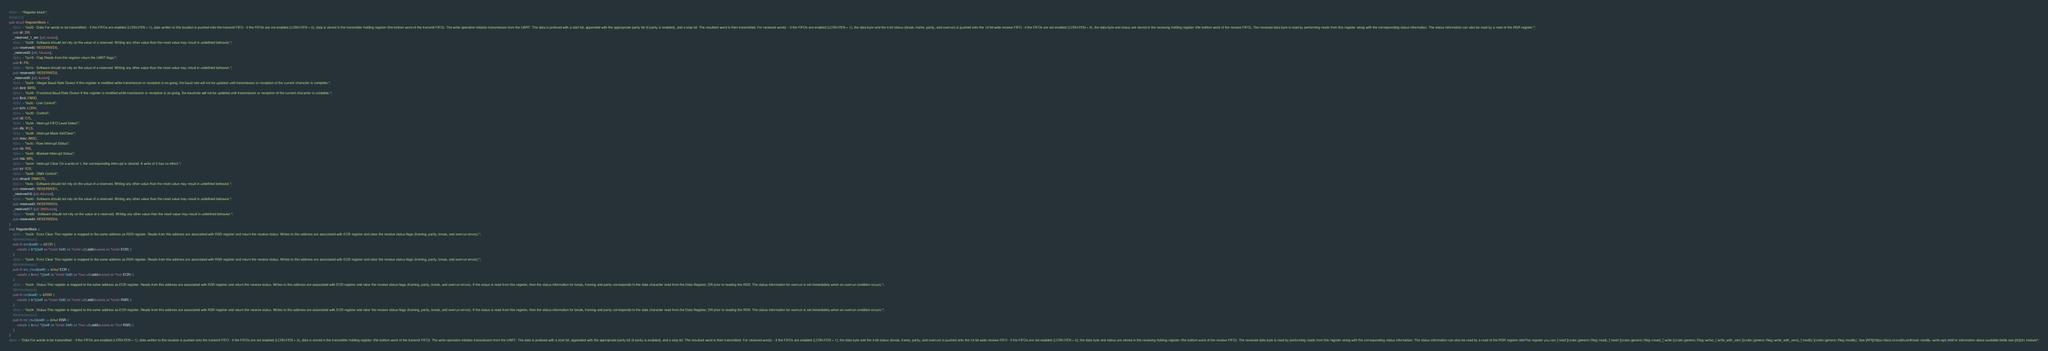<code> <loc_0><loc_0><loc_500><loc_500><_Rust_>#[doc = r"Register block"]
#[repr(C)]
pub struct RegisterBlock {
    #[doc = "0x00 - Data For words to be transmitted: - if the FIFOs are enabled (LCRH.FEN = 1), data written to this location is pushed onto the transmit FIFO - if the FIFOs are not enabled (LCRH.FEN = 0), data is stored in the transmitter holding register (the bottom word of the transmit FIFO). The write operation initiates transmission from the UART. The data is prefixed with a start bit, appended with the appropriate parity bit (if parity is enabled), and a stop bit. The resultant word is then transmitted. For received words: - if the FIFOs are enabled (LCRH.FEN = 1), the data byte and the 4-bit status (break, frame, parity, and overrun) is pushed onto the 12-bit wide receive FIFO - if the FIFOs are not enabled (LCRH.FEN = 0), the data byte and status are stored in the receiving holding register (the bottom word of the receive FIFO). The received data byte is read by performing reads from this register along with the corresponding status information. The status information can also be read by a read of the RSR register."]
    pub dr: DR,
    _reserved_1_ecr: [u8; 4usize],
    #[doc = "0x08 - Software should not rely on the value of a reserved. Writing any other value than the reset value may result in undefined behavior."]
    pub reserved0: RESERVED0,
    _reserved3: [u8; 12usize],
    #[doc = "0x18 - Flag Reads from this register return the UART flags."]
    pub fr: FR,
    #[doc = "0x1c - Software should not rely on the value of a reserved. Writing any other value than the reset value may result in undefined behavior."]
    pub reserved2: RESERVED2,
    _reserved5: [u8; 4usize],
    #[doc = "0x24 - Integer Baud-Rate Divisor If this register is modified while transmission or reception is on-going, the baud rate will not be updated until transmission or reception of the current character is complete."]
    pub ibrd: IBRD,
    #[doc = "0x28 - Fractional Baud-Rate Divisor If this register is modified while trasmission or reception is on-going, the baudrate will not be updated until transmission or reception of the current character is complete."]
    pub fbrd: FBRD,
    #[doc = "0x2c - Line Control"]
    pub lcrh: LCRH,
    #[doc = "0x30 - Control"]
    pub ctl: CTL,
    #[doc = "0x34 - Interrupt FIFO Level Select"]
    pub ifls: IFLS,
    #[doc = "0x38 - Interrupt Mask Set/Clear"]
    pub imsc: IMSC,
    #[doc = "0x3c - Raw Interrupt Status"]
    pub ris: RIS,
    #[doc = "0x40 - Masked Interrupt Status"]
    pub mis: MIS,
    #[doc = "0x44 - Interrupt Clear On a write of 1, the corresponding interrupt is cleared. A write of 0 has no effect."]
    pub icr: ICR,
    #[doc = "0x48 - DMA Control"]
    pub dmactl: DMACTL,
    #[doc = "0x4c - Software should not rely on the value of a reserved. Writing any other value than the reset value may result in undefined behavior."]
    pub reserved1: RESERVED1,
    _reserved16: [u8; 64usize],
    #[doc = "0x90 - Software should not rely on the value of a reserved. Writing any other value than the reset value may result in undefined behavior."]
    pub reserved3: RESERVED3,
    _reserved17: [u8; 3900usize],
    #[doc = "0xfd0 - Software should not rely on the value of a reserved. Writing any other value than the reset value may result in undefined behavior."]
    pub reserved4: RESERVED4,
}
impl RegisterBlock {
    #[doc = "0x04 - Error Clear This register is mapped to the same address as RSR register. Reads from this address are associated with RSR register and return the receive status. Writes to this address are associated with ECR register and clear the receive status flags (framing, parity, break, and overrun errors)."]
    #[inline(always)]
    pub fn ecr(&self) -> &ECR {
        unsafe { &*(((self as *const Self) as *const u8).add(4usize) as *const ECR) }
    }
    #[doc = "0x04 - Error Clear This register is mapped to the same address as RSR register. Reads from this address are associated with RSR register and return the receive status. Writes to this address are associated with ECR register and clear the receive status flags (framing, parity, break, and overrun errors)."]
    #[inline(always)]
    pub fn ecr_mut(&self) -> &mut ECR {
        unsafe { &mut *(((self as *const Self) as *mut u8).add(4usize) as *mut ECR) }
    }
    #[doc = "0x04 - Status This register is mapped to the same address as ECR register. Reads from this address are associated with RSR register and return the receive status. Writes to this address are associated with ECR register and clear the receive status flags (framing, parity, break, and overrun errors). If the status is read from this register, then the status information for break, framing and parity corresponds to the data character read from the Data Register, DR prior to reading the RSR. The status information for overrun is set immediately when an overrun condition occurs."]
    #[inline(always)]
    pub fn rsr(&self) -> &RSR {
        unsafe { &*(((self as *const Self) as *const u8).add(4usize) as *const RSR) }
    }
    #[doc = "0x04 - Status This register is mapped to the same address as ECR register. Reads from this address are associated with RSR register and return the receive status. Writes to this address are associated with ECR register and clear the receive status flags (framing, parity, break, and overrun errors). If the status is read from this register, then the status information for break, framing and parity corresponds to the data character read from the Data Register, DR prior to reading the RSR. The status information for overrun is set immediately when an overrun condition occurs."]
    #[inline(always)]
    pub fn rsr_mut(&self) -> &mut RSR {
        unsafe { &mut *(((self as *const Self) as *mut u8).add(4usize) as *mut RSR) }
    }
}
#[doc = "Data For words to be transmitted: - if the FIFOs are enabled (LCRH.FEN = 1), data written to this location is pushed onto the transmit FIFO - if the FIFOs are not enabled (LCRH.FEN = 0), data is stored in the transmitter holding register (the bottom word of the transmit FIFO). The write operation initiates transmission from the UART. The data is prefixed with a start bit, appended with the appropriate parity bit (if parity is enabled), and a stop bit. The resultant word is then transmitted. For received words: - if the FIFOs are enabled (LCRH.FEN = 1), the data byte and the 4-bit status (break, frame, parity, and overrun) is pushed onto the 12-bit wide receive FIFO - if the FIFOs are not enabled (LCRH.FEN = 0), the data byte and status are stored in the receiving holding register (the bottom word of the receive FIFO). The received data byte is read by performing reads from this register along with the corresponding status information. The status information can also be read by a read of the RSR register.\n\nThis register you can [`read`](crate::generic::Reg::read), [`reset`](crate::generic::Reg::reset), [`write`](crate::generic::Reg::write), [`write_with_zero`](crate::generic::Reg::write_with_zero), [`modify`](crate::generic::Reg::modify). See [API](https://docs.rs/svd2rust/#read--modify--write-api).\n\nFor information about available fields see [dr](dr) module"]</code> 